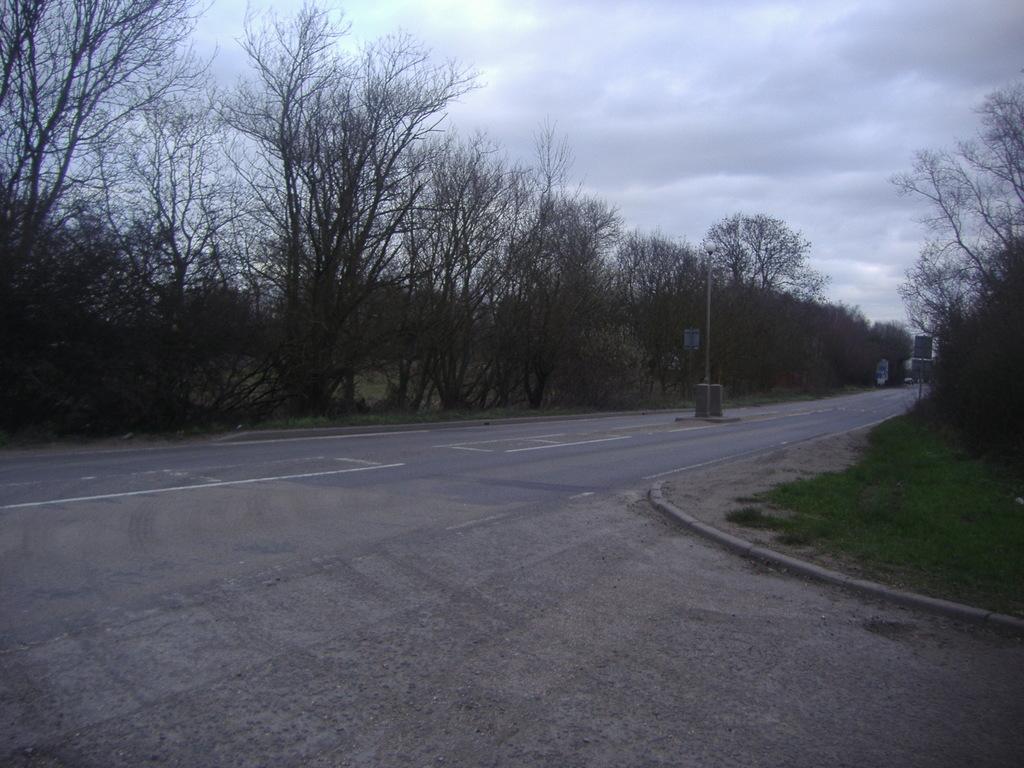Please provide a concise description of this image. In this image we can see a road. On the both sides of the road, we can see grassy land and trees. There is a pole in the middle of the image. At the top of the image, we can see the sky with clouds. 